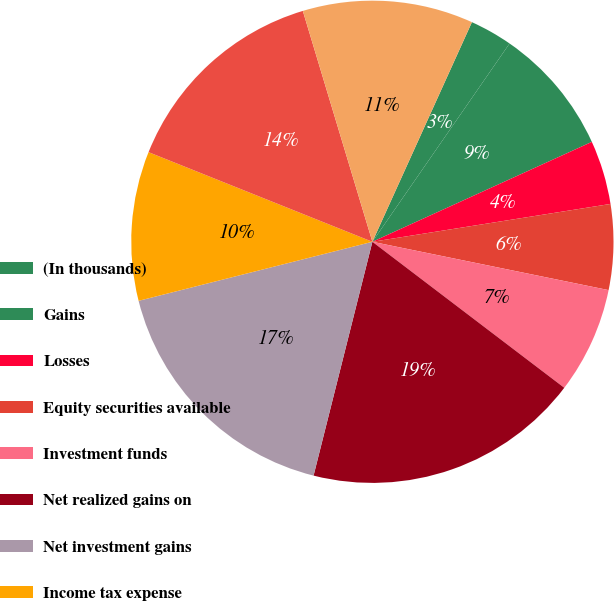<chart> <loc_0><loc_0><loc_500><loc_500><pie_chart><fcel>(In thousands)<fcel>Gains<fcel>Losses<fcel>Equity securities available<fcel>Investment funds<fcel>Net realized gains on<fcel>Net investment gains<fcel>Income tax expense<fcel>After-tax realized investment<fcel>Fixed maturity securities<nl><fcel>2.86%<fcel>8.57%<fcel>4.29%<fcel>5.72%<fcel>7.14%<fcel>18.57%<fcel>17.14%<fcel>10.0%<fcel>14.28%<fcel>11.43%<nl></chart> 